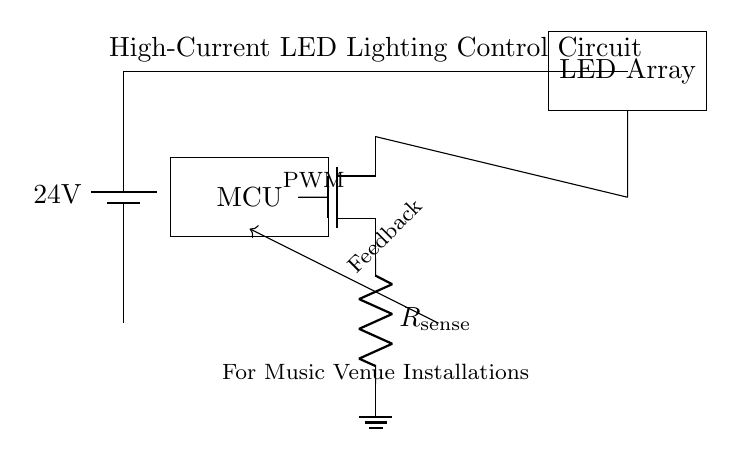What is the voltage of the power supply? The voltage of the power supply is indicated next to the battery symbol, which shows it as 24 volts.
Answer: 24 volts What does the MCU control in this circuit? The MCU (Microcontroller Unit) controls the MOSFET gate, which in turn regulates the current to the LED array based on the PWM signal.
Answer: MOSFET What kind of component is used for current sensing? The component used for current sensing is a resistor, specifically labeled as R with the subscript "sense," indicating its role in measuring the current flowing through it.
Answer: Resistor How are the LED Array and the MOSFET connected? The LED array is connected to the drain of the MOSFET, which allows the current from the power supply to flow through the LED array when the MOSFET is activated.
Answer: Drain connection What feedback mechanism is shown in the circuit? A feedback line is drawn from the MOSFET to the MCU, indicated by an arrow, suggesting that the MCU receives information about the circuit's operation for dynamic control.
Answer: Feedback line What is the function of the PWM signal? The PWM signal from the MCU is used to modulate the control of the MOSFET gate, allowing for variable control over the LED brightness by adjusting the current flowing through the LED array.
Answer: Modulation of brightness 